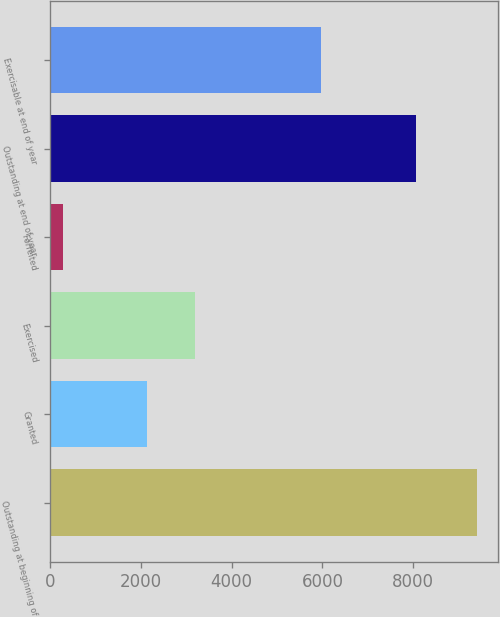<chart> <loc_0><loc_0><loc_500><loc_500><bar_chart><fcel>Outstanding at beginning of<fcel>Granted<fcel>Exercised<fcel>Forfeited<fcel>Outstanding at end of year<fcel>Exercisable at end of year<nl><fcel>9402<fcel>2134<fcel>3187<fcel>287<fcel>8062<fcel>5962<nl></chart> 